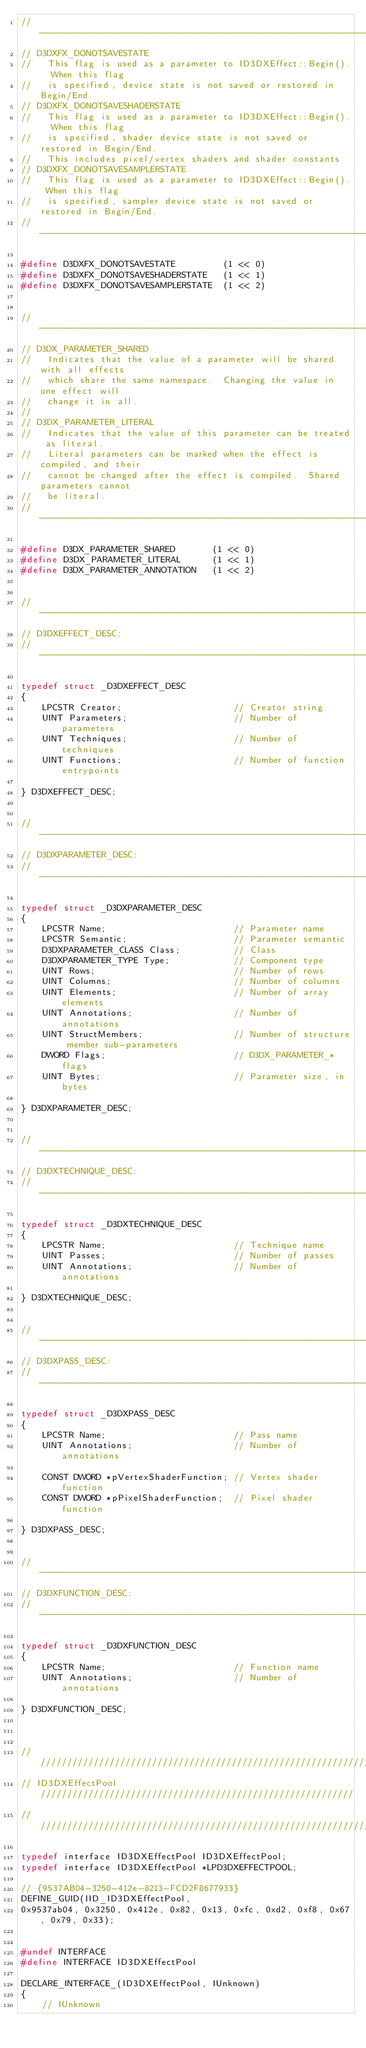Convert code to text. <code><loc_0><loc_0><loc_500><loc_500><_C_>//----------------------------------------------------------------------------
// D3DXFX_DONOTSAVESTATE
//   This flag is used as a parameter to ID3DXEffect::Begin().  When this flag
//   is specified, device state is not saved or restored in Begin/End.
// D3DXFX_DONOTSAVESHADERSTATE
//   This flag is used as a parameter to ID3DXEffect::Begin().  When this flag
//   is specified, shader device state is not saved or restored in Begin/End.
//   This includes pixel/vertex shaders and shader constants
// D3DXFX_DONOTSAVESAMPLERSTATE
//   This flag is used as a parameter to ID3DXEffect::Begin(). When this flag
//   is specified, sampler device state is not saved or restored in Begin/End.
//----------------------------------------------------------------------------

#define D3DXFX_DONOTSAVESTATE         (1 << 0)
#define D3DXFX_DONOTSAVESHADERSTATE   (1 << 1)
#define D3DXFX_DONOTSAVESAMPLERSTATE  (1 << 2)


//----------------------------------------------------------------------------
// D3DX_PARAMETER_SHARED
//   Indicates that the value of a parameter will be shared with all effects
//   which share the same namespace.  Changing the value in one effect will
//   change it in all.
//
// D3DX_PARAMETER_LITERAL
//   Indicates that the value of this parameter can be treated as literal.
//   Literal parameters can be marked when the effect is compiled, and their
//   cannot be changed after the effect is compiled.  Shared parameters cannot
//   be literal.
//----------------------------------------------------------------------------

#define D3DX_PARAMETER_SHARED       (1 << 0)
#define D3DX_PARAMETER_LITERAL      (1 << 1)
#define D3DX_PARAMETER_ANNOTATION   (1 << 2)


//----------------------------------------------------------------------------
// D3DXEFFECT_DESC:
//----------------------------------------------------------------------------

typedef struct _D3DXEFFECT_DESC
{
    LPCSTR Creator;                     // Creator string
    UINT Parameters;                    // Number of parameters
    UINT Techniques;                    // Number of techniques
    UINT Functions;                     // Number of function entrypoints

} D3DXEFFECT_DESC;


//----------------------------------------------------------------------------
// D3DXPARAMETER_DESC:
//----------------------------------------------------------------------------

typedef struct _D3DXPARAMETER_DESC
{
    LPCSTR Name;                        // Parameter name
    LPCSTR Semantic;                    // Parameter semantic
    D3DXPARAMETER_CLASS Class;          // Class
    D3DXPARAMETER_TYPE Type;            // Component type
    UINT Rows;                          // Number of rows
    UINT Columns;                       // Number of columns
    UINT Elements;                      // Number of array elements
    UINT Annotations;                   // Number of annotations
    UINT StructMembers;                 // Number of structure member sub-parameters
    DWORD Flags;                        // D3DX_PARAMETER_* flags
    UINT Bytes;                         // Parameter size, in bytes

} D3DXPARAMETER_DESC;


//----------------------------------------------------------------------------
// D3DXTECHNIQUE_DESC:
//----------------------------------------------------------------------------

typedef struct _D3DXTECHNIQUE_DESC
{
    LPCSTR Name;                        // Technique name
    UINT Passes;                        // Number of passes
    UINT Annotations;                   // Number of annotations

} D3DXTECHNIQUE_DESC;


//----------------------------------------------------------------------------
// D3DXPASS_DESC:
//----------------------------------------------------------------------------

typedef struct _D3DXPASS_DESC
{
    LPCSTR Name;                        // Pass name
    UINT Annotations;                   // Number of annotations

    CONST DWORD *pVertexShaderFunction; // Vertex shader function
    CONST DWORD *pPixelShaderFunction;  // Pixel shader function

} D3DXPASS_DESC;


//----------------------------------------------------------------------------
// D3DXFUNCTION_DESC:
//----------------------------------------------------------------------------

typedef struct _D3DXFUNCTION_DESC
{
    LPCSTR Name;                        // Function name
    UINT Annotations;                   // Number of annotations

} D3DXFUNCTION_DESC;



//////////////////////////////////////////////////////////////////////////////
// ID3DXEffectPool ///////////////////////////////////////////////////////////
//////////////////////////////////////////////////////////////////////////////

typedef interface ID3DXEffectPool ID3DXEffectPool;
typedef interface ID3DXEffectPool *LPD3DXEFFECTPOOL;

// {9537AB04-3250-412e-8213-FCD2F8677933}
DEFINE_GUID(IID_ID3DXEffectPool, 
0x9537ab04, 0x3250, 0x412e, 0x82, 0x13, 0xfc, 0xd2, 0xf8, 0x67, 0x79, 0x33);


#undef INTERFACE
#define INTERFACE ID3DXEffectPool

DECLARE_INTERFACE_(ID3DXEffectPool, IUnknown)
{
    // IUnknown</code> 